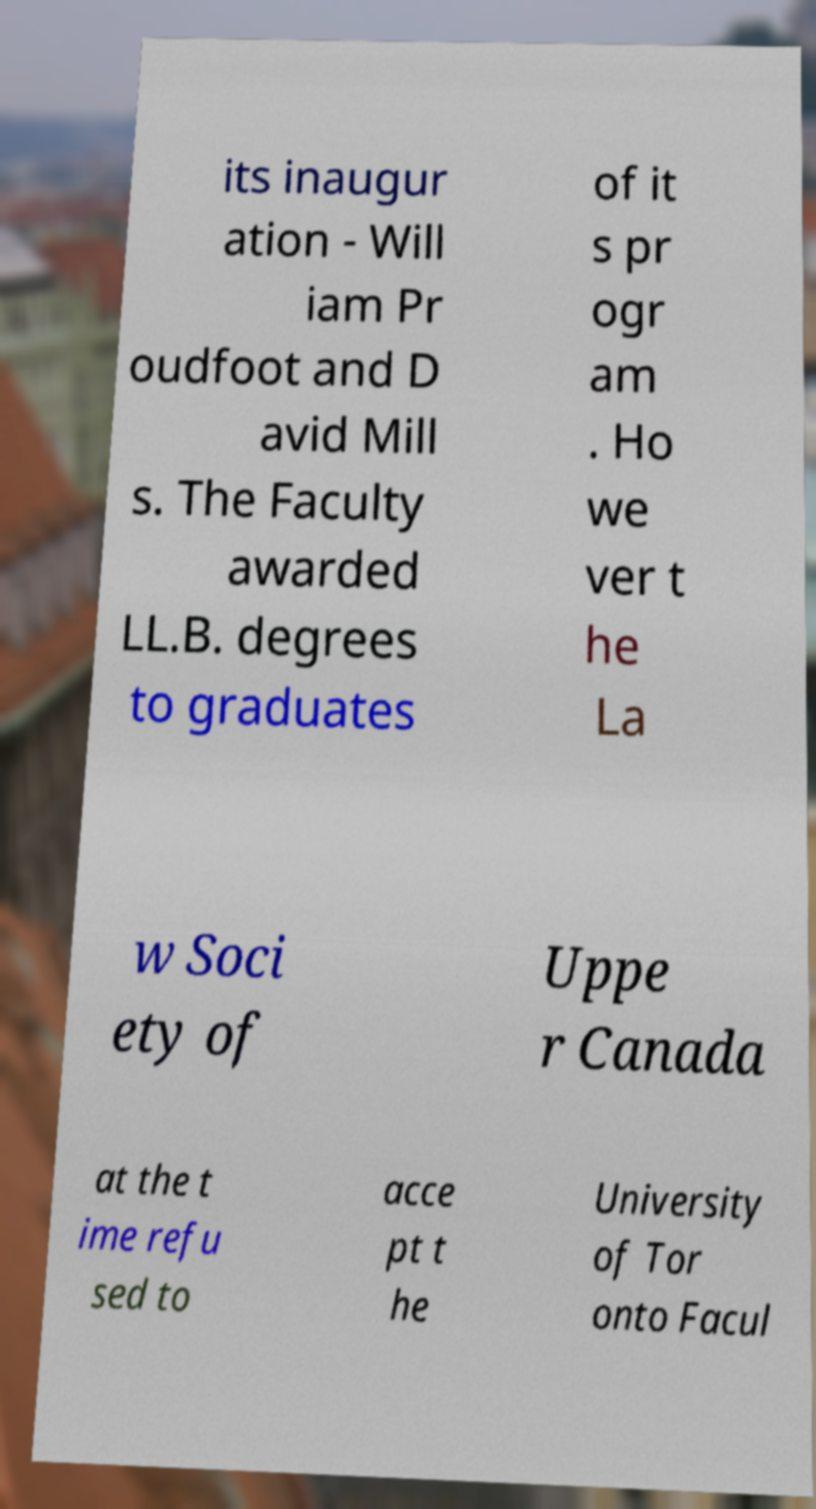What messages or text are displayed in this image? I need them in a readable, typed format. its inaugur ation - Will iam Pr oudfoot and D avid Mill s. The Faculty awarded LL.B. degrees to graduates of it s pr ogr am . Ho we ver t he La w Soci ety of Uppe r Canada at the t ime refu sed to acce pt t he University of Tor onto Facul 